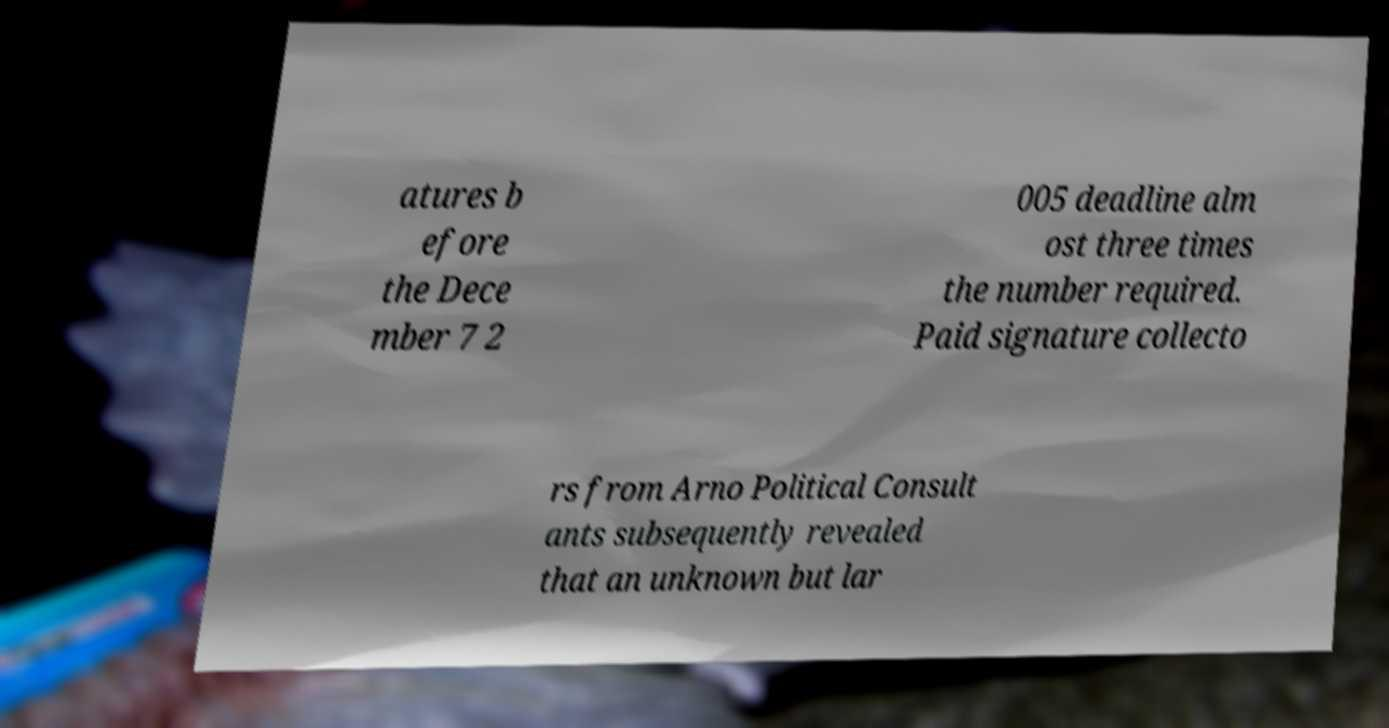I need the written content from this picture converted into text. Can you do that? atures b efore the Dece mber 7 2 005 deadline alm ost three times the number required. Paid signature collecto rs from Arno Political Consult ants subsequently revealed that an unknown but lar 